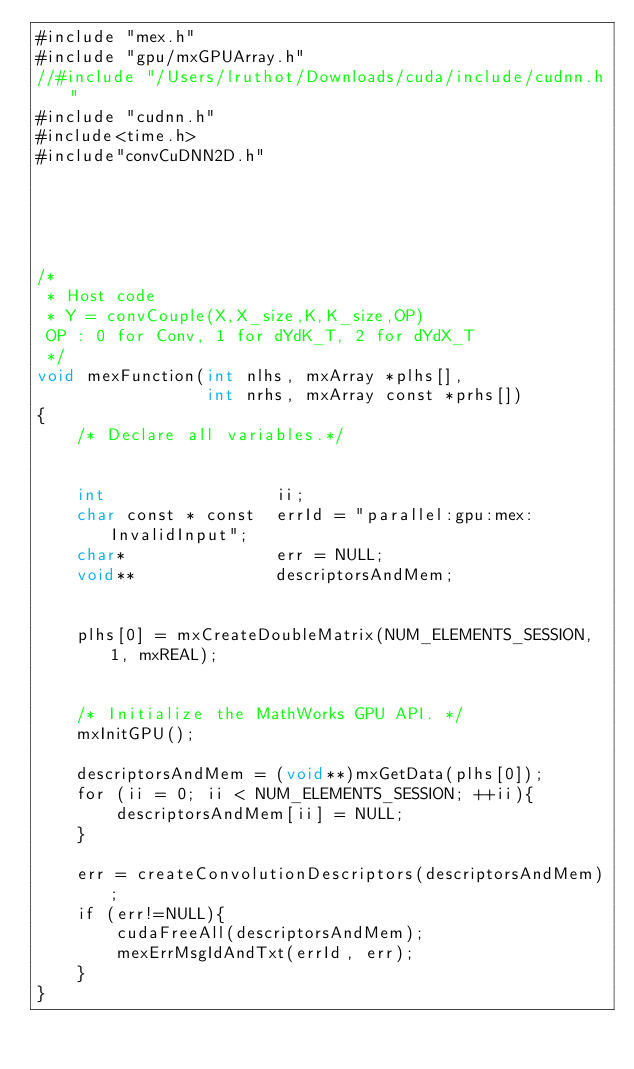Convert code to text. <code><loc_0><loc_0><loc_500><loc_500><_Cuda_>#include "mex.h"
#include "gpu/mxGPUArray.h"
//#include "/Users/lruthot/Downloads/cuda/include/cudnn.h"
#include "cudnn.h"
#include<time.h>
#include"convCuDNN2D.h"





/*
 * Host code
 * Y = convCouple(X,X_size,K,K_size,OP)
 OP : 0 for Conv, 1 for dYdK_T, 2 for dYdX_T
 */
void mexFunction(int nlhs, mxArray *plhs[],
                 int nrhs, mxArray const *prhs[])
{
    /* Declare all variables.*/
 		

	int 				ii;
    char const * const 	errId = "parallel:gpu:mex:InvalidInput";
	char* 				err = NULL;
	void**				descriptorsAndMem;

	
	plhs[0] = mxCreateDoubleMatrix(NUM_ELEMENTS_SESSION, 1, mxREAL);
	
	
    /* Initialize the MathWorks GPU API. */
	mxInitGPU();
	
	descriptorsAndMem = (void**)mxGetData(plhs[0]);
	for (ii = 0; ii < NUM_ELEMENTS_SESSION; ++ii){
		descriptorsAndMem[ii] = NULL;
	}
	
	err = createConvolutionDescriptors(descriptorsAndMem);
	if (err!=NULL){
		cudaFreeAll(descriptorsAndMem);
		mexErrMsgIdAndTxt(errId, err);
	}
}</code> 